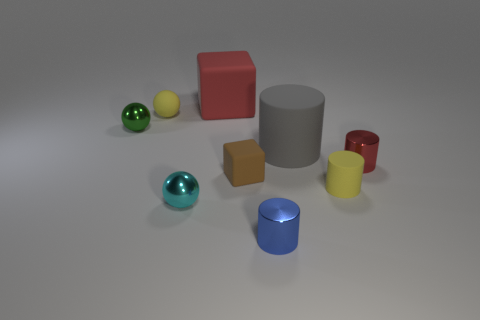What color is the small matte block?
Offer a very short reply. Brown. What is the shape of the green object that is made of the same material as the small blue object?
Your answer should be compact. Sphere. Is the size of the yellow matte thing that is to the right of the blue metallic cylinder the same as the small red shiny cylinder?
Make the answer very short. Yes. What number of objects are tiny yellow matte objects that are in front of the small red metal object or yellow things to the left of the big red object?
Keep it short and to the point. 2. Does the big thing that is in front of the red rubber object have the same color as the small cube?
Provide a succinct answer. No. How many matte things are small spheres or small cyan things?
Make the answer very short. 1. What is the shape of the brown rubber object?
Provide a short and direct response. Cube. Is there any other thing that has the same material as the small cyan thing?
Make the answer very short. Yes. Are the gray thing and the tiny cyan sphere made of the same material?
Make the answer very short. No. Are there any yellow things that are on the left side of the yellow matte object on the right side of the small matte object that is behind the tiny green shiny ball?
Give a very brief answer. Yes. 